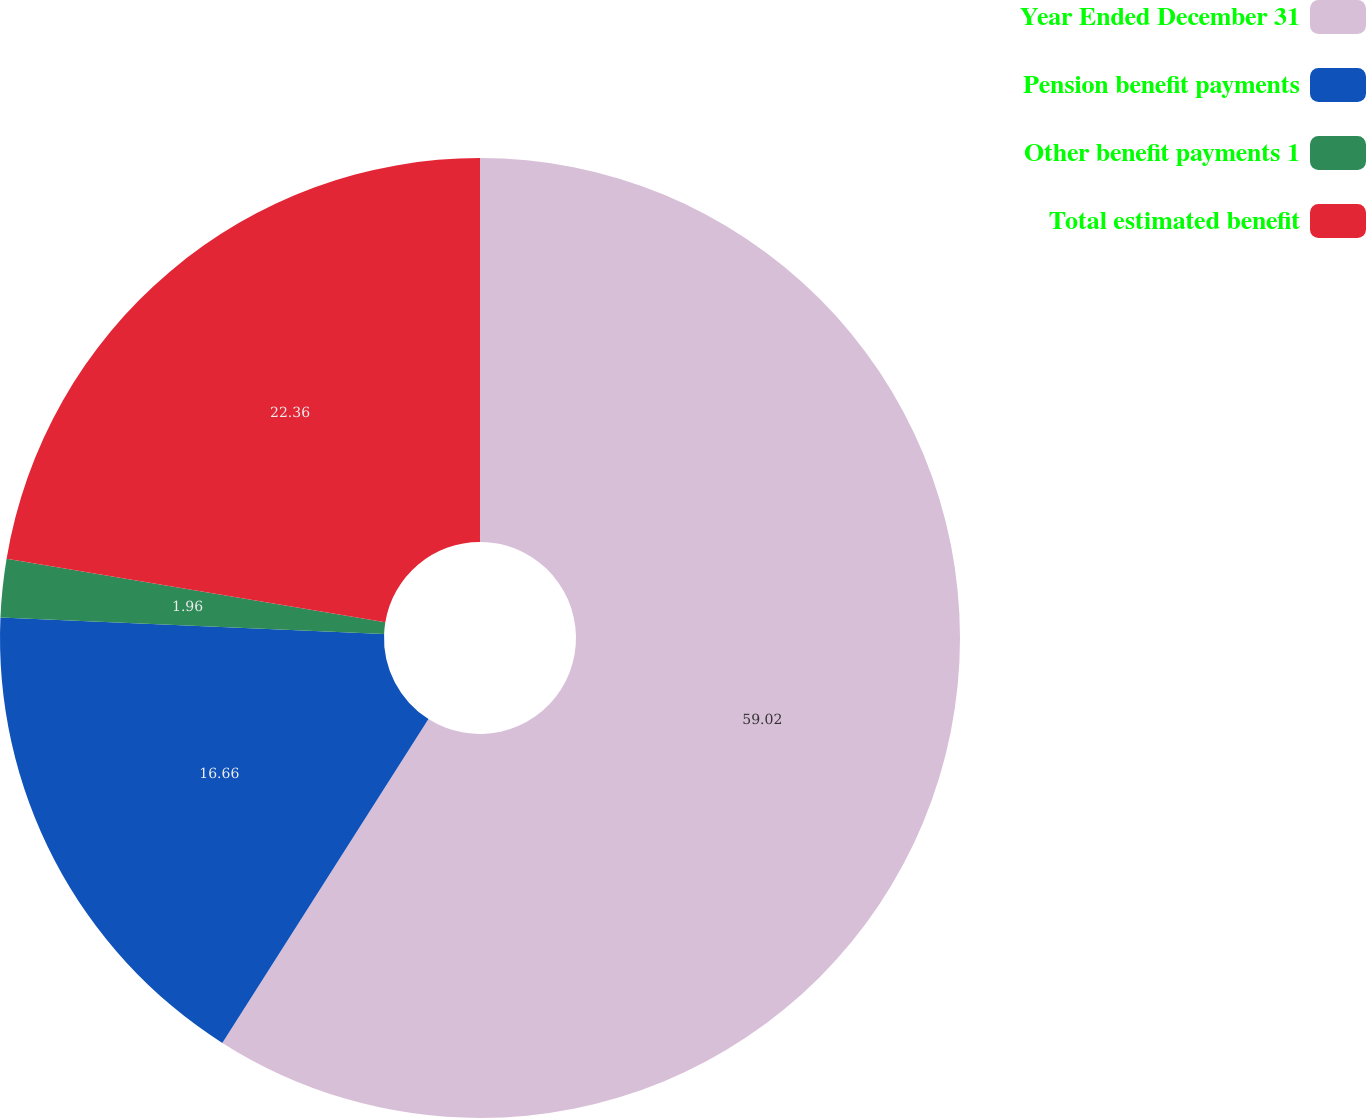Convert chart to OTSL. <chart><loc_0><loc_0><loc_500><loc_500><pie_chart><fcel>Year Ended December 31<fcel>Pension benefit payments<fcel>Other benefit payments 1<fcel>Total estimated benefit<nl><fcel>59.02%<fcel>16.66%<fcel>1.96%<fcel>22.36%<nl></chart> 